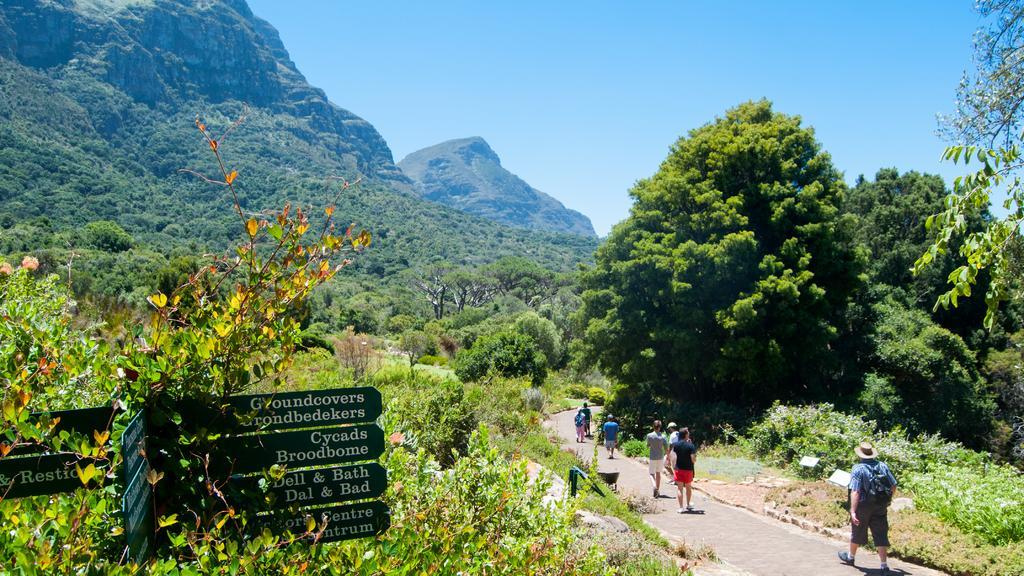Can you describe this image briefly? In this image, we can see so many trees, planted, hills and few objects. On the left side bottom of the image, we can see name boards. Here we can see few people are walking through the walkway. Background there is the sky. 